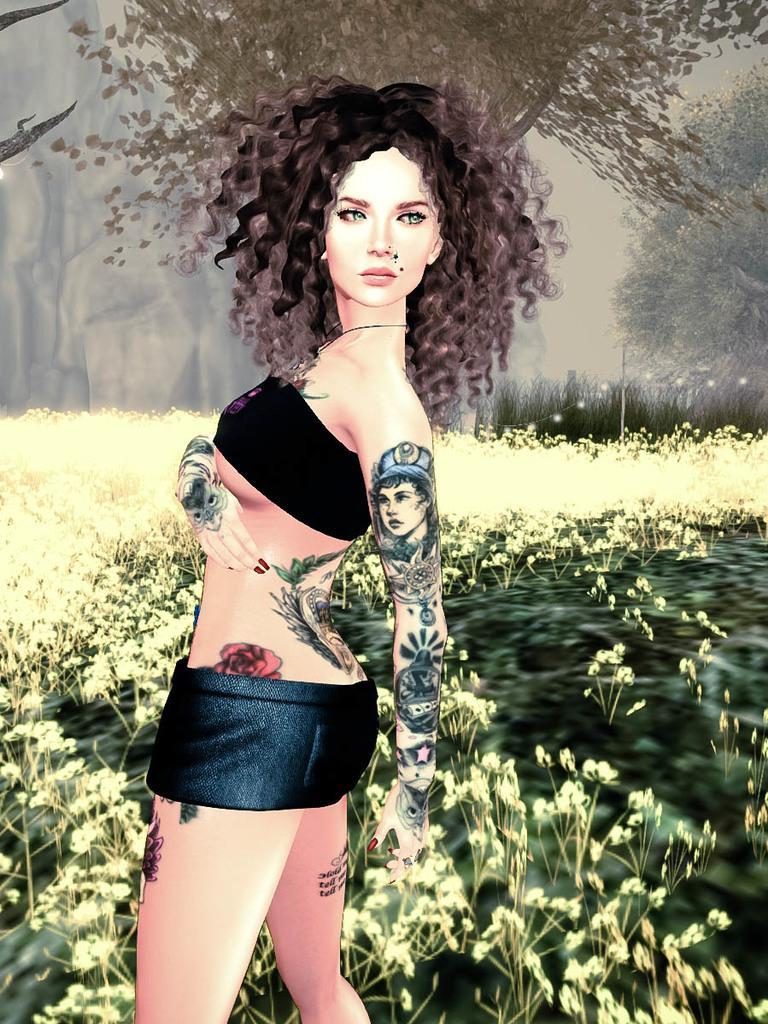How would you summarize this image in a sentence or two? It is an animated image, in this a girl is looking at this side, she wore black color top and short. There are Tattoos on her hand, at the back side there are plants and trees. On the left side there is a hill. 